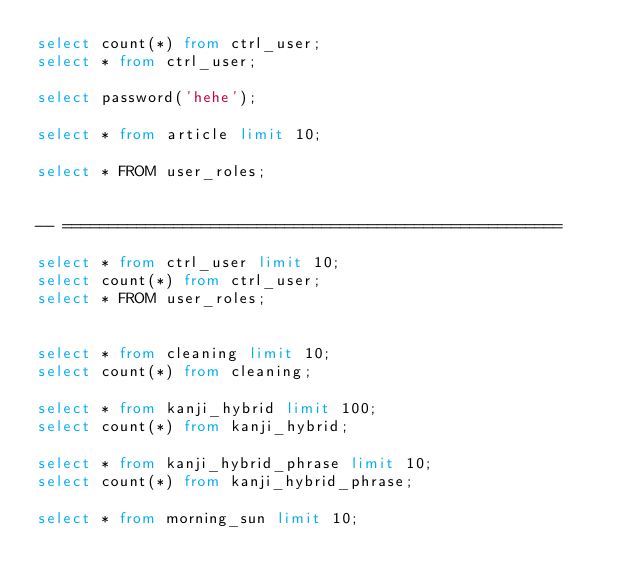<code> <loc_0><loc_0><loc_500><loc_500><_SQL_>select count(*) from ctrl_user;
select * from ctrl_user;

select password('hehe');

select * from article limit 10;

select * FROM user_roles;


-- ======================================================

select * from ctrl_user limit 10;
select count(*) from ctrl_user;
select * FROM user_roles;


select * from cleaning limit 10;
select count(*) from cleaning;

select * from kanji_hybrid limit 100;
select count(*) from kanji_hybrid;

select * from kanji_hybrid_phrase limit 10;
select count(*) from kanji_hybrid_phrase;

select * from morning_sun limit 10;</code> 